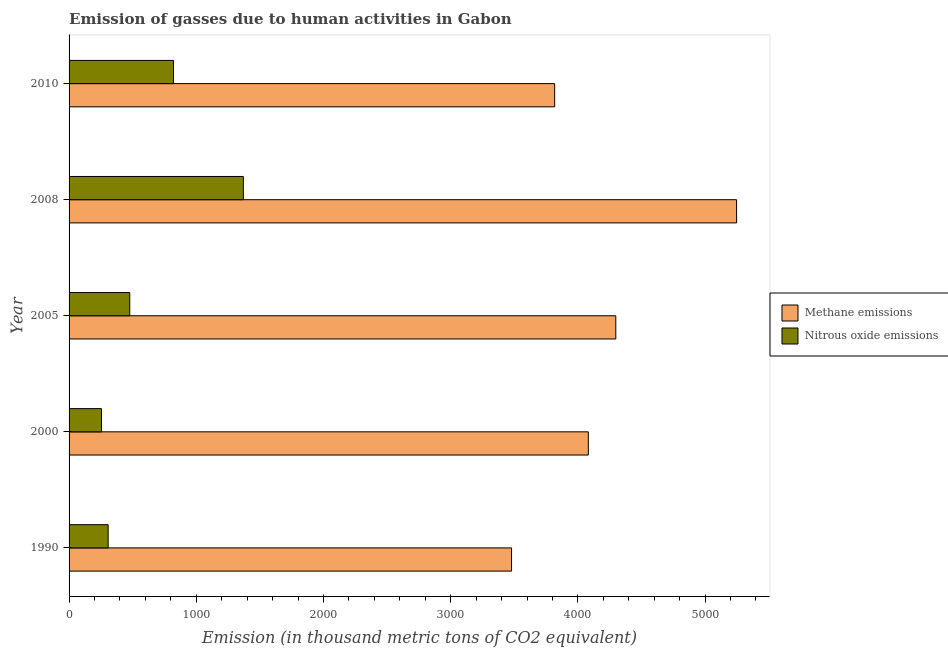How many groups of bars are there?
Offer a terse response. 5. Are the number of bars per tick equal to the number of legend labels?
Give a very brief answer. Yes. What is the label of the 4th group of bars from the top?
Ensure brevity in your answer.  2000. In how many cases, is the number of bars for a given year not equal to the number of legend labels?
Your answer should be compact. 0. What is the amount of nitrous oxide emissions in 1990?
Make the answer very short. 307.1. Across all years, what is the maximum amount of nitrous oxide emissions?
Provide a succinct answer. 1370. Across all years, what is the minimum amount of nitrous oxide emissions?
Your response must be concise. 254.9. What is the total amount of methane emissions in the graph?
Your answer should be compact. 2.09e+04. What is the difference between the amount of methane emissions in 2000 and that in 2005?
Your answer should be compact. -216. What is the difference between the amount of nitrous oxide emissions in 2005 and the amount of methane emissions in 1990?
Keep it short and to the point. -3001.4. What is the average amount of nitrous oxide emissions per year?
Offer a terse response. 646.08. In the year 2000, what is the difference between the amount of nitrous oxide emissions and amount of methane emissions?
Your answer should be compact. -3827.2. In how many years, is the amount of nitrous oxide emissions greater than 3800 thousand metric tons?
Give a very brief answer. 0. What is the ratio of the amount of methane emissions in 1990 to that in 2008?
Provide a short and direct response. 0.66. Is the amount of nitrous oxide emissions in 2005 less than that in 2010?
Give a very brief answer. Yes. Is the difference between the amount of methane emissions in 2005 and 2008 greater than the difference between the amount of nitrous oxide emissions in 2005 and 2008?
Offer a terse response. No. What is the difference between the highest and the second highest amount of nitrous oxide emissions?
Offer a very short reply. 548.7. What is the difference between the highest and the lowest amount of nitrous oxide emissions?
Provide a succinct answer. 1115.1. In how many years, is the amount of nitrous oxide emissions greater than the average amount of nitrous oxide emissions taken over all years?
Keep it short and to the point. 2. What does the 2nd bar from the top in 2005 represents?
Give a very brief answer. Methane emissions. What does the 2nd bar from the bottom in 2010 represents?
Offer a terse response. Nitrous oxide emissions. Are the values on the major ticks of X-axis written in scientific E-notation?
Your answer should be very brief. No. Does the graph contain any zero values?
Your answer should be compact. No. How many legend labels are there?
Make the answer very short. 2. What is the title of the graph?
Your response must be concise. Emission of gasses due to human activities in Gabon. What is the label or title of the X-axis?
Provide a succinct answer. Emission (in thousand metric tons of CO2 equivalent). What is the label or title of the Y-axis?
Keep it short and to the point. Year. What is the Emission (in thousand metric tons of CO2 equivalent) of Methane emissions in 1990?
Keep it short and to the point. 3478.5. What is the Emission (in thousand metric tons of CO2 equivalent) of Nitrous oxide emissions in 1990?
Give a very brief answer. 307.1. What is the Emission (in thousand metric tons of CO2 equivalent) in Methane emissions in 2000?
Offer a terse response. 4082.1. What is the Emission (in thousand metric tons of CO2 equivalent) in Nitrous oxide emissions in 2000?
Provide a succinct answer. 254.9. What is the Emission (in thousand metric tons of CO2 equivalent) of Methane emissions in 2005?
Ensure brevity in your answer.  4298.1. What is the Emission (in thousand metric tons of CO2 equivalent) in Nitrous oxide emissions in 2005?
Your answer should be compact. 477.1. What is the Emission (in thousand metric tons of CO2 equivalent) of Methane emissions in 2008?
Give a very brief answer. 5247.8. What is the Emission (in thousand metric tons of CO2 equivalent) in Nitrous oxide emissions in 2008?
Offer a terse response. 1370. What is the Emission (in thousand metric tons of CO2 equivalent) of Methane emissions in 2010?
Make the answer very short. 3817.5. What is the Emission (in thousand metric tons of CO2 equivalent) in Nitrous oxide emissions in 2010?
Provide a succinct answer. 821.3. Across all years, what is the maximum Emission (in thousand metric tons of CO2 equivalent) in Methane emissions?
Provide a succinct answer. 5247.8. Across all years, what is the maximum Emission (in thousand metric tons of CO2 equivalent) in Nitrous oxide emissions?
Your answer should be very brief. 1370. Across all years, what is the minimum Emission (in thousand metric tons of CO2 equivalent) of Methane emissions?
Make the answer very short. 3478.5. Across all years, what is the minimum Emission (in thousand metric tons of CO2 equivalent) in Nitrous oxide emissions?
Provide a succinct answer. 254.9. What is the total Emission (in thousand metric tons of CO2 equivalent) in Methane emissions in the graph?
Make the answer very short. 2.09e+04. What is the total Emission (in thousand metric tons of CO2 equivalent) in Nitrous oxide emissions in the graph?
Provide a succinct answer. 3230.4. What is the difference between the Emission (in thousand metric tons of CO2 equivalent) in Methane emissions in 1990 and that in 2000?
Your answer should be very brief. -603.6. What is the difference between the Emission (in thousand metric tons of CO2 equivalent) of Nitrous oxide emissions in 1990 and that in 2000?
Your answer should be very brief. 52.2. What is the difference between the Emission (in thousand metric tons of CO2 equivalent) in Methane emissions in 1990 and that in 2005?
Keep it short and to the point. -819.6. What is the difference between the Emission (in thousand metric tons of CO2 equivalent) in Nitrous oxide emissions in 1990 and that in 2005?
Offer a very short reply. -170. What is the difference between the Emission (in thousand metric tons of CO2 equivalent) of Methane emissions in 1990 and that in 2008?
Give a very brief answer. -1769.3. What is the difference between the Emission (in thousand metric tons of CO2 equivalent) of Nitrous oxide emissions in 1990 and that in 2008?
Ensure brevity in your answer.  -1062.9. What is the difference between the Emission (in thousand metric tons of CO2 equivalent) of Methane emissions in 1990 and that in 2010?
Offer a terse response. -339. What is the difference between the Emission (in thousand metric tons of CO2 equivalent) in Nitrous oxide emissions in 1990 and that in 2010?
Your response must be concise. -514.2. What is the difference between the Emission (in thousand metric tons of CO2 equivalent) in Methane emissions in 2000 and that in 2005?
Offer a very short reply. -216. What is the difference between the Emission (in thousand metric tons of CO2 equivalent) in Nitrous oxide emissions in 2000 and that in 2005?
Ensure brevity in your answer.  -222.2. What is the difference between the Emission (in thousand metric tons of CO2 equivalent) in Methane emissions in 2000 and that in 2008?
Offer a very short reply. -1165.7. What is the difference between the Emission (in thousand metric tons of CO2 equivalent) of Nitrous oxide emissions in 2000 and that in 2008?
Offer a terse response. -1115.1. What is the difference between the Emission (in thousand metric tons of CO2 equivalent) in Methane emissions in 2000 and that in 2010?
Keep it short and to the point. 264.6. What is the difference between the Emission (in thousand metric tons of CO2 equivalent) in Nitrous oxide emissions in 2000 and that in 2010?
Make the answer very short. -566.4. What is the difference between the Emission (in thousand metric tons of CO2 equivalent) in Methane emissions in 2005 and that in 2008?
Make the answer very short. -949.7. What is the difference between the Emission (in thousand metric tons of CO2 equivalent) of Nitrous oxide emissions in 2005 and that in 2008?
Provide a short and direct response. -892.9. What is the difference between the Emission (in thousand metric tons of CO2 equivalent) of Methane emissions in 2005 and that in 2010?
Provide a short and direct response. 480.6. What is the difference between the Emission (in thousand metric tons of CO2 equivalent) of Nitrous oxide emissions in 2005 and that in 2010?
Your answer should be compact. -344.2. What is the difference between the Emission (in thousand metric tons of CO2 equivalent) of Methane emissions in 2008 and that in 2010?
Ensure brevity in your answer.  1430.3. What is the difference between the Emission (in thousand metric tons of CO2 equivalent) of Nitrous oxide emissions in 2008 and that in 2010?
Your response must be concise. 548.7. What is the difference between the Emission (in thousand metric tons of CO2 equivalent) of Methane emissions in 1990 and the Emission (in thousand metric tons of CO2 equivalent) of Nitrous oxide emissions in 2000?
Offer a very short reply. 3223.6. What is the difference between the Emission (in thousand metric tons of CO2 equivalent) of Methane emissions in 1990 and the Emission (in thousand metric tons of CO2 equivalent) of Nitrous oxide emissions in 2005?
Keep it short and to the point. 3001.4. What is the difference between the Emission (in thousand metric tons of CO2 equivalent) of Methane emissions in 1990 and the Emission (in thousand metric tons of CO2 equivalent) of Nitrous oxide emissions in 2008?
Offer a terse response. 2108.5. What is the difference between the Emission (in thousand metric tons of CO2 equivalent) in Methane emissions in 1990 and the Emission (in thousand metric tons of CO2 equivalent) in Nitrous oxide emissions in 2010?
Your answer should be very brief. 2657.2. What is the difference between the Emission (in thousand metric tons of CO2 equivalent) in Methane emissions in 2000 and the Emission (in thousand metric tons of CO2 equivalent) in Nitrous oxide emissions in 2005?
Offer a terse response. 3605. What is the difference between the Emission (in thousand metric tons of CO2 equivalent) in Methane emissions in 2000 and the Emission (in thousand metric tons of CO2 equivalent) in Nitrous oxide emissions in 2008?
Your answer should be very brief. 2712.1. What is the difference between the Emission (in thousand metric tons of CO2 equivalent) in Methane emissions in 2000 and the Emission (in thousand metric tons of CO2 equivalent) in Nitrous oxide emissions in 2010?
Provide a short and direct response. 3260.8. What is the difference between the Emission (in thousand metric tons of CO2 equivalent) in Methane emissions in 2005 and the Emission (in thousand metric tons of CO2 equivalent) in Nitrous oxide emissions in 2008?
Provide a short and direct response. 2928.1. What is the difference between the Emission (in thousand metric tons of CO2 equivalent) in Methane emissions in 2005 and the Emission (in thousand metric tons of CO2 equivalent) in Nitrous oxide emissions in 2010?
Offer a terse response. 3476.8. What is the difference between the Emission (in thousand metric tons of CO2 equivalent) in Methane emissions in 2008 and the Emission (in thousand metric tons of CO2 equivalent) in Nitrous oxide emissions in 2010?
Make the answer very short. 4426.5. What is the average Emission (in thousand metric tons of CO2 equivalent) of Methane emissions per year?
Offer a terse response. 4184.8. What is the average Emission (in thousand metric tons of CO2 equivalent) of Nitrous oxide emissions per year?
Make the answer very short. 646.08. In the year 1990, what is the difference between the Emission (in thousand metric tons of CO2 equivalent) in Methane emissions and Emission (in thousand metric tons of CO2 equivalent) in Nitrous oxide emissions?
Provide a short and direct response. 3171.4. In the year 2000, what is the difference between the Emission (in thousand metric tons of CO2 equivalent) in Methane emissions and Emission (in thousand metric tons of CO2 equivalent) in Nitrous oxide emissions?
Your answer should be compact. 3827.2. In the year 2005, what is the difference between the Emission (in thousand metric tons of CO2 equivalent) in Methane emissions and Emission (in thousand metric tons of CO2 equivalent) in Nitrous oxide emissions?
Your answer should be very brief. 3821. In the year 2008, what is the difference between the Emission (in thousand metric tons of CO2 equivalent) of Methane emissions and Emission (in thousand metric tons of CO2 equivalent) of Nitrous oxide emissions?
Your answer should be very brief. 3877.8. In the year 2010, what is the difference between the Emission (in thousand metric tons of CO2 equivalent) of Methane emissions and Emission (in thousand metric tons of CO2 equivalent) of Nitrous oxide emissions?
Provide a succinct answer. 2996.2. What is the ratio of the Emission (in thousand metric tons of CO2 equivalent) in Methane emissions in 1990 to that in 2000?
Keep it short and to the point. 0.85. What is the ratio of the Emission (in thousand metric tons of CO2 equivalent) of Nitrous oxide emissions in 1990 to that in 2000?
Your answer should be compact. 1.2. What is the ratio of the Emission (in thousand metric tons of CO2 equivalent) of Methane emissions in 1990 to that in 2005?
Your response must be concise. 0.81. What is the ratio of the Emission (in thousand metric tons of CO2 equivalent) of Nitrous oxide emissions in 1990 to that in 2005?
Keep it short and to the point. 0.64. What is the ratio of the Emission (in thousand metric tons of CO2 equivalent) of Methane emissions in 1990 to that in 2008?
Offer a terse response. 0.66. What is the ratio of the Emission (in thousand metric tons of CO2 equivalent) in Nitrous oxide emissions in 1990 to that in 2008?
Ensure brevity in your answer.  0.22. What is the ratio of the Emission (in thousand metric tons of CO2 equivalent) of Methane emissions in 1990 to that in 2010?
Your answer should be very brief. 0.91. What is the ratio of the Emission (in thousand metric tons of CO2 equivalent) of Nitrous oxide emissions in 1990 to that in 2010?
Your response must be concise. 0.37. What is the ratio of the Emission (in thousand metric tons of CO2 equivalent) of Methane emissions in 2000 to that in 2005?
Offer a terse response. 0.95. What is the ratio of the Emission (in thousand metric tons of CO2 equivalent) in Nitrous oxide emissions in 2000 to that in 2005?
Give a very brief answer. 0.53. What is the ratio of the Emission (in thousand metric tons of CO2 equivalent) in Methane emissions in 2000 to that in 2008?
Offer a very short reply. 0.78. What is the ratio of the Emission (in thousand metric tons of CO2 equivalent) in Nitrous oxide emissions in 2000 to that in 2008?
Provide a short and direct response. 0.19. What is the ratio of the Emission (in thousand metric tons of CO2 equivalent) in Methane emissions in 2000 to that in 2010?
Offer a terse response. 1.07. What is the ratio of the Emission (in thousand metric tons of CO2 equivalent) in Nitrous oxide emissions in 2000 to that in 2010?
Make the answer very short. 0.31. What is the ratio of the Emission (in thousand metric tons of CO2 equivalent) of Methane emissions in 2005 to that in 2008?
Provide a succinct answer. 0.82. What is the ratio of the Emission (in thousand metric tons of CO2 equivalent) of Nitrous oxide emissions in 2005 to that in 2008?
Provide a succinct answer. 0.35. What is the ratio of the Emission (in thousand metric tons of CO2 equivalent) of Methane emissions in 2005 to that in 2010?
Your answer should be compact. 1.13. What is the ratio of the Emission (in thousand metric tons of CO2 equivalent) of Nitrous oxide emissions in 2005 to that in 2010?
Ensure brevity in your answer.  0.58. What is the ratio of the Emission (in thousand metric tons of CO2 equivalent) in Methane emissions in 2008 to that in 2010?
Keep it short and to the point. 1.37. What is the ratio of the Emission (in thousand metric tons of CO2 equivalent) of Nitrous oxide emissions in 2008 to that in 2010?
Your answer should be very brief. 1.67. What is the difference between the highest and the second highest Emission (in thousand metric tons of CO2 equivalent) of Methane emissions?
Ensure brevity in your answer.  949.7. What is the difference between the highest and the second highest Emission (in thousand metric tons of CO2 equivalent) of Nitrous oxide emissions?
Ensure brevity in your answer.  548.7. What is the difference between the highest and the lowest Emission (in thousand metric tons of CO2 equivalent) in Methane emissions?
Your response must be concise. 1769.3. What is the difference between the highest and the lowest Emission (in thousand metric tons of CO2 equivalent) in Nitrous oxide emissions?
Provide a short and direct response. 1115.1. 